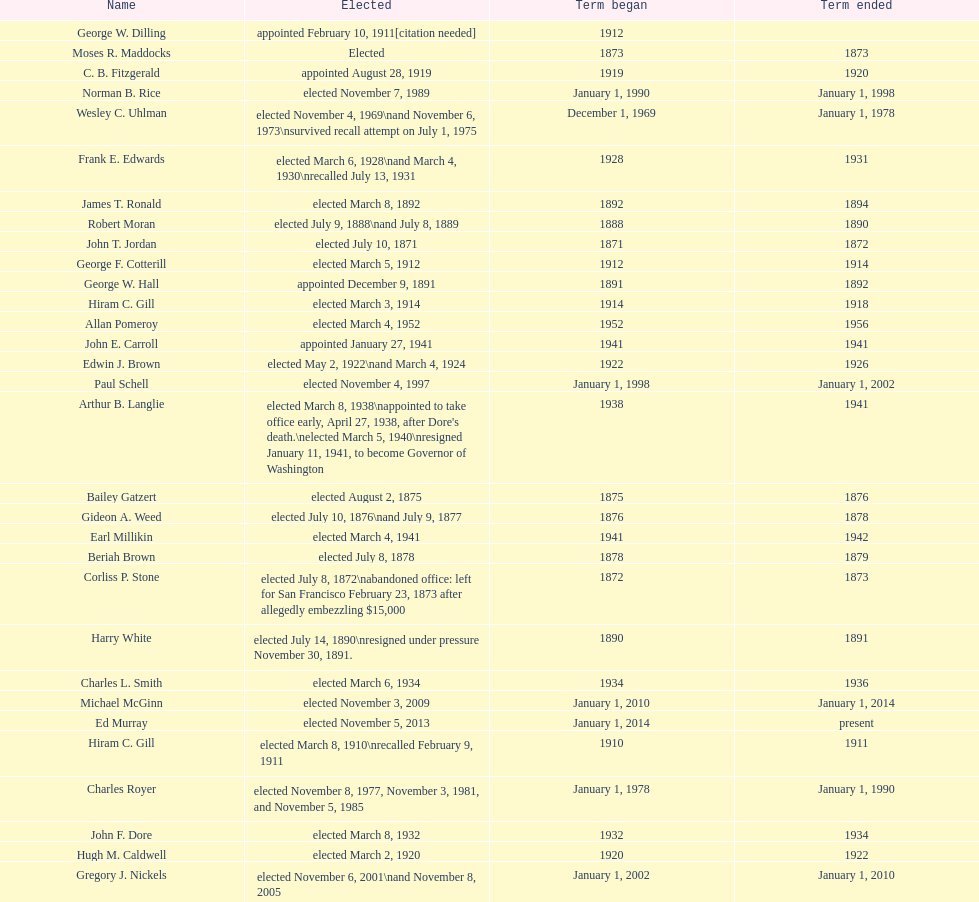How many days did robert moran serve? 365. 